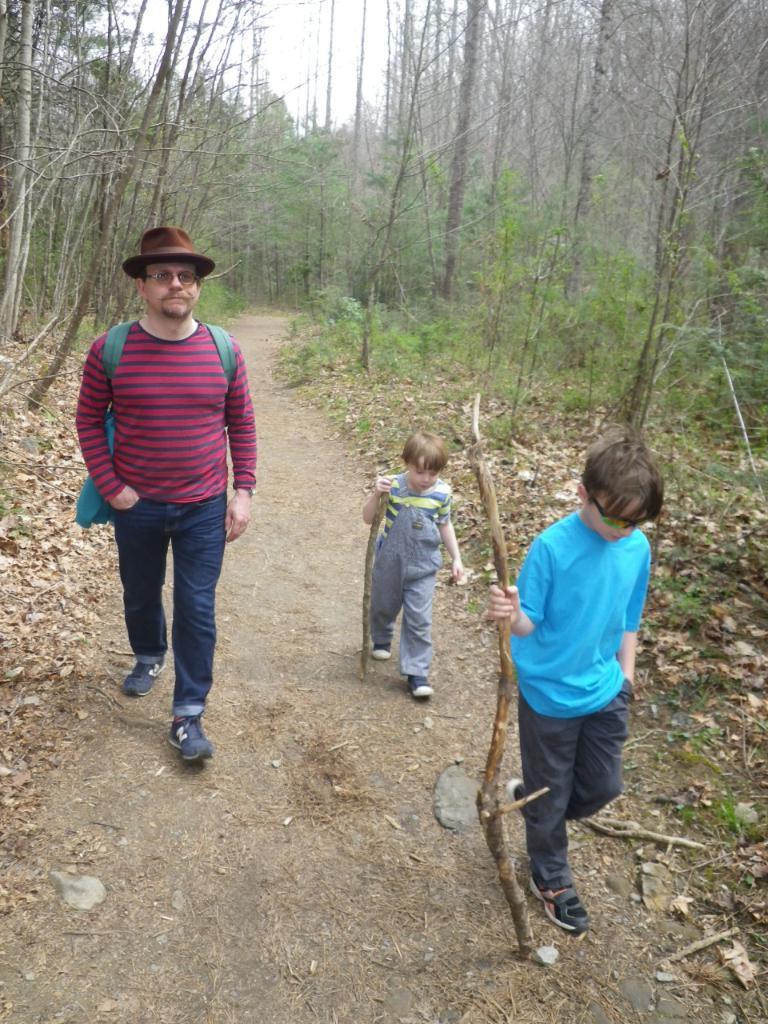Can you describe this image briefly? In the center of the image we can see one person and two kids are walking on the road. Among them, we can see two kids are holding some objects and one person is wearing a bag and a hat. In the background, we can see the sky, trees, grass and dry leaves. 